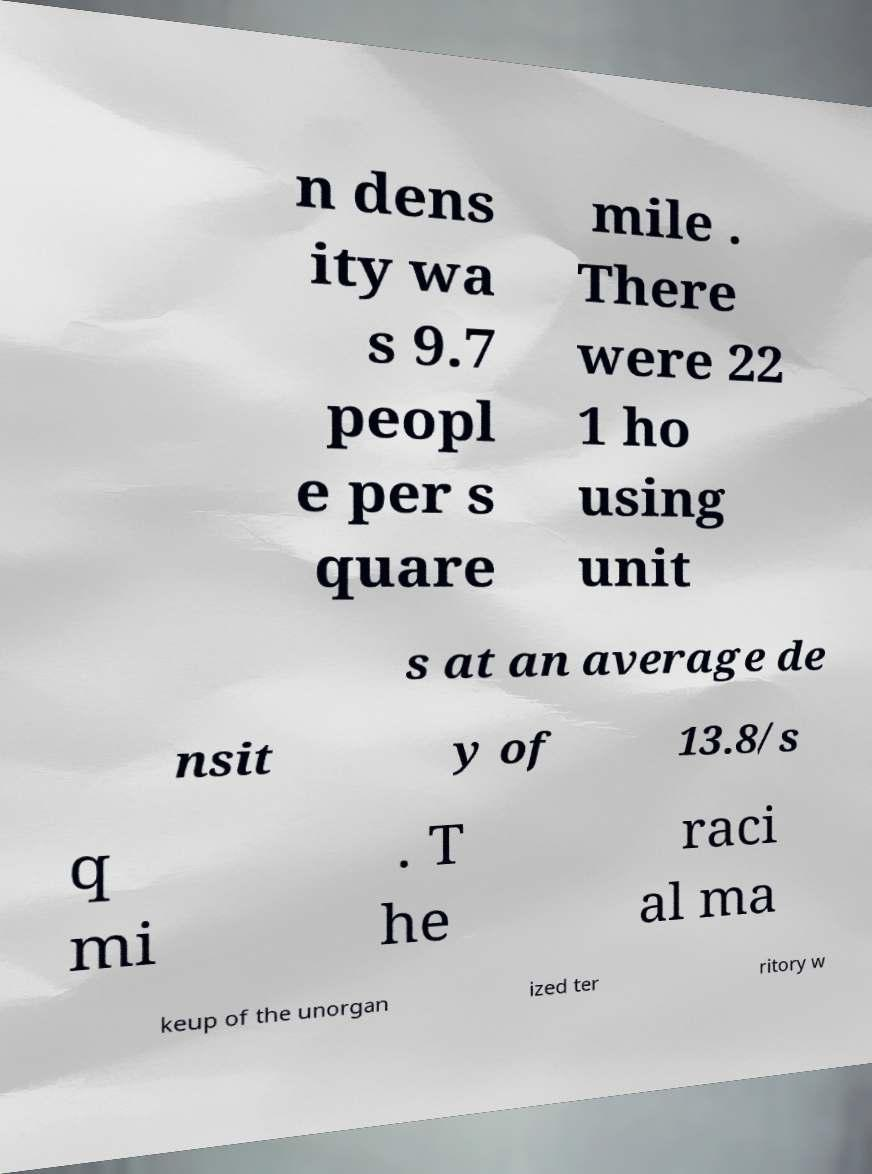For documentation purposes, I need the text within this image transcribed. Could you provide that? n dens ity wa s 9.7 peopl e per s quare mile . There were 22 1 ho using unit s at an average de nsit y of 13.8/s q mi . T he raci al ma keup of the unorgan ized ter ritory w 